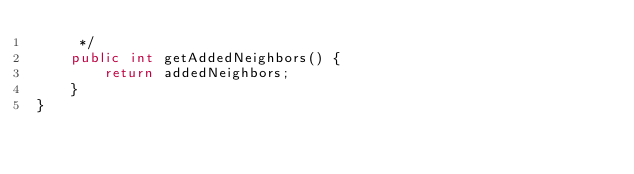Convert code to text. <code><loc_0><loc_0><loc_500><loc_500><_Java_>     */
    public int getAddedNeighbors() {
        return addedNeighbors;
    }
}
</code> 